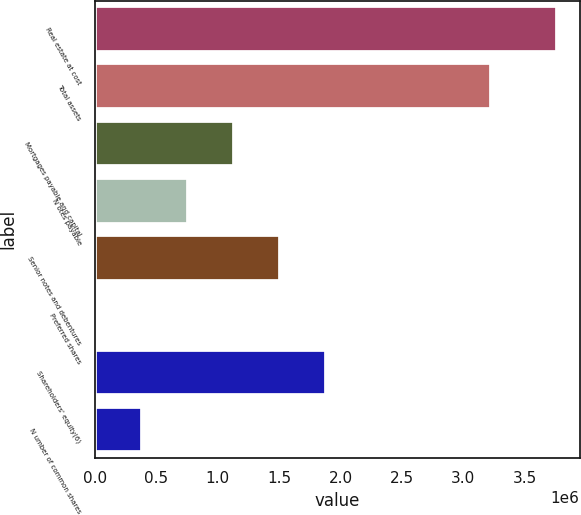Convert chart to OTSL. <chart><loc_0><loc_0><loc_500><loc_500><bar_chart><fcel>Real estate at cost<fcel>Total assets<fcel>Mortgages payable and capital<fcel>N otes payable<fcel>Senior notes and debentures<fcel>Preferred shares<fcel>Shareholders' equity(6)<fcel>N umber of common shares<nl><fcel>3.75923e+06<fcel>3.22231e+06<fcel>1.13477e+06<fcel>759844<fcel>1.50969e+06<fcel>9997<fcel>1.88462e+06<fcel>384921<nl></chart> 